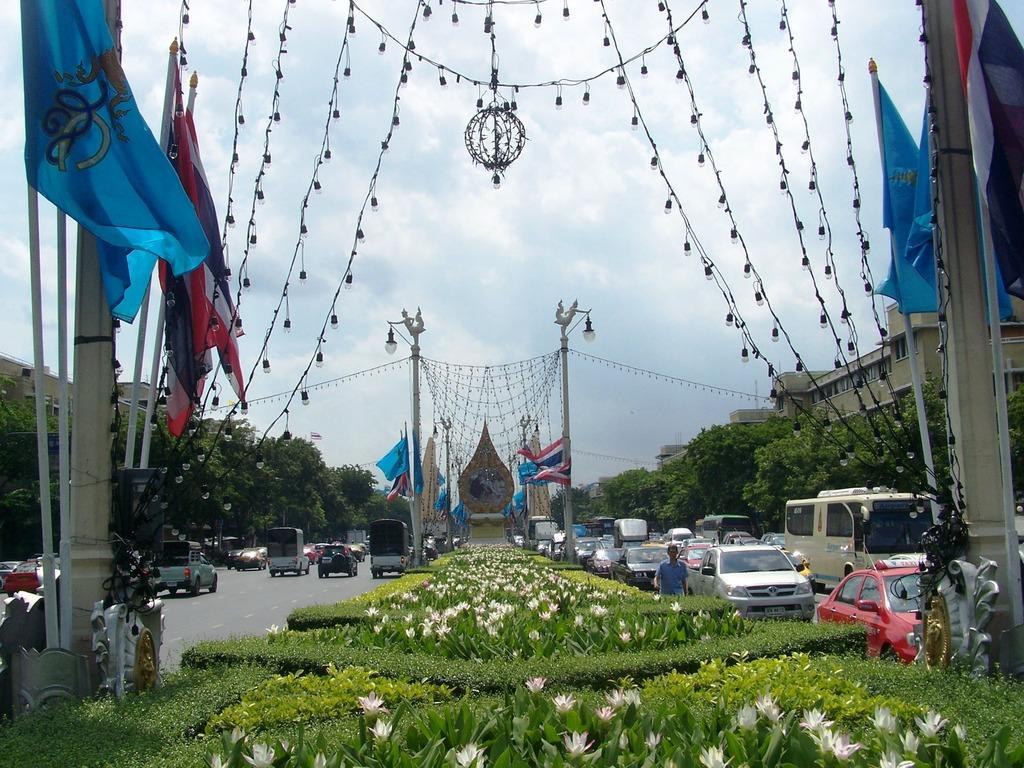In one or two sentences, can you explain what this image depicts? At the bottom of the image there are bushes with flowers. On the roads there are vehicles. And there are poles with statues and lamps and also there are decorative lights. And there is a pedestal with a statue. There are pillars with lights and poles with flags. In the background there are trees and buildings. And also there is sky with clouds. 